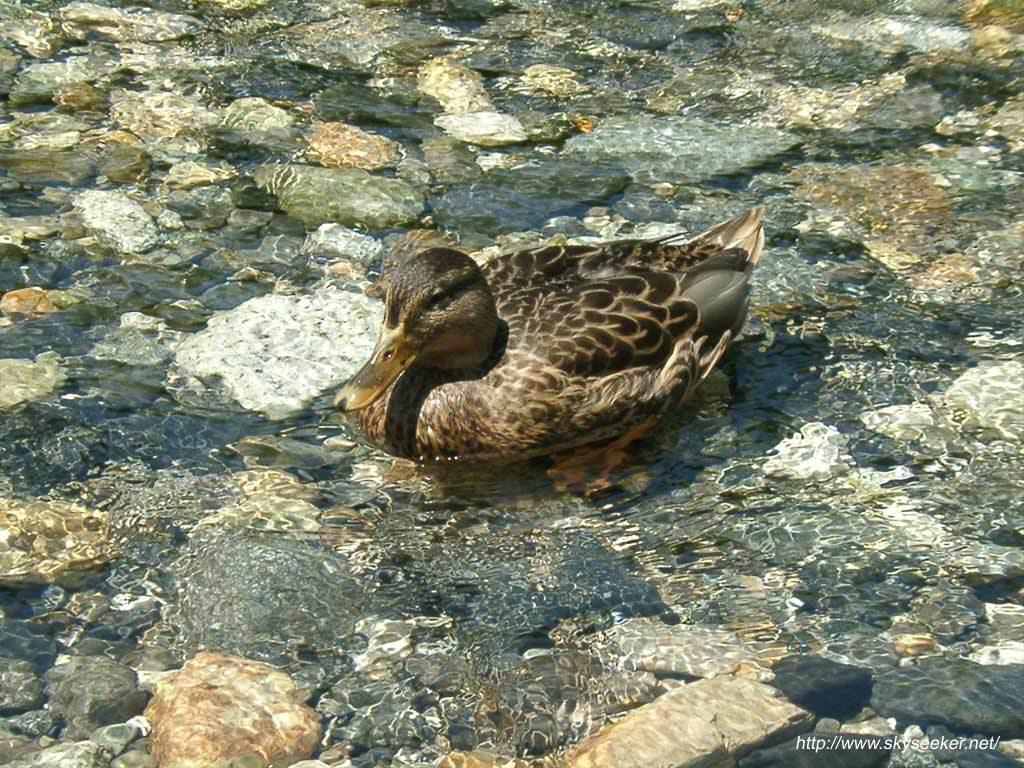In one or two sentences, can you explain what this image depicts? In this image we can see a bird on the water. In the background, we can see the rocks. In the bottom right we can see some text. 